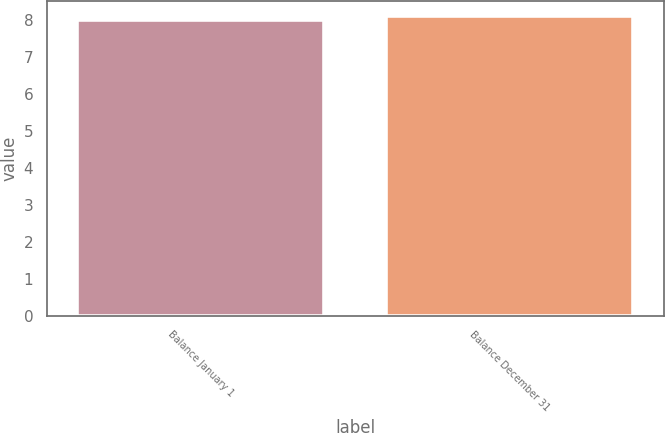Convert chart. <chart><loc_0><loc_0><loc_500><loc_500><bar_chart><fcel>Balance January 1<fcel>Balance December 31<nl><fcel>8<fcel>8.1<nl></chart> 